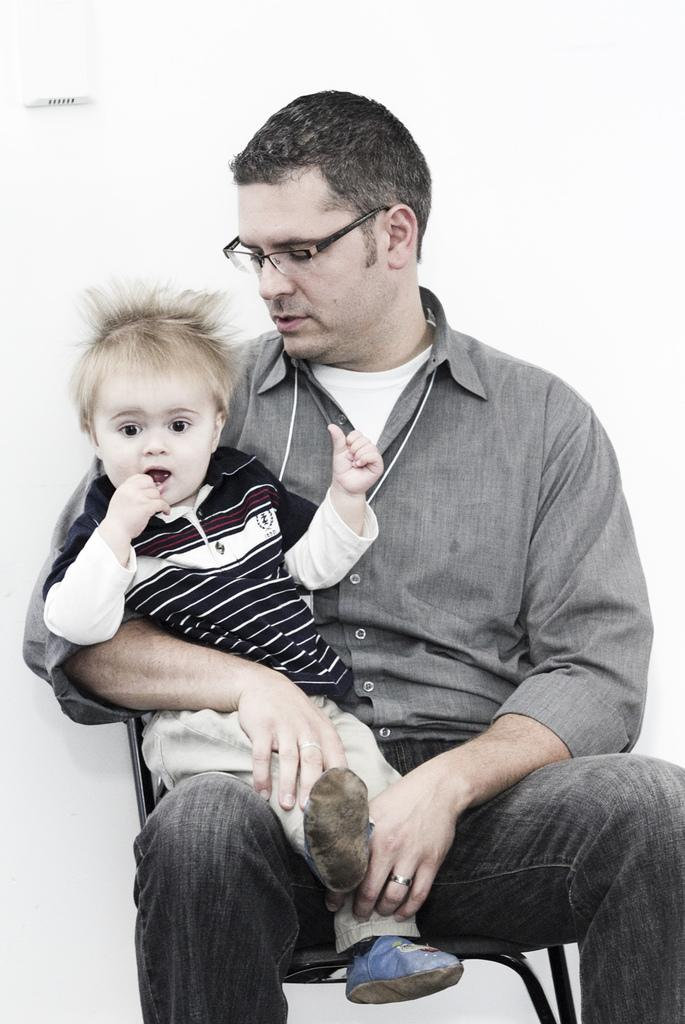What is the man in the image doing? The man is sitting in the image and holding a baby. What is the man wearing in the image? The man is wearing a shirt and jeans in the image. What accessory is the man wearing in the image? The man is wearing specs in the image. What is the color of the background in the image? The background of the image is white. How many crayons are visible in the image? There are no crayons present in the image. What type of toothbrush is the man using in the image? There is no toothbrush present in the image. 